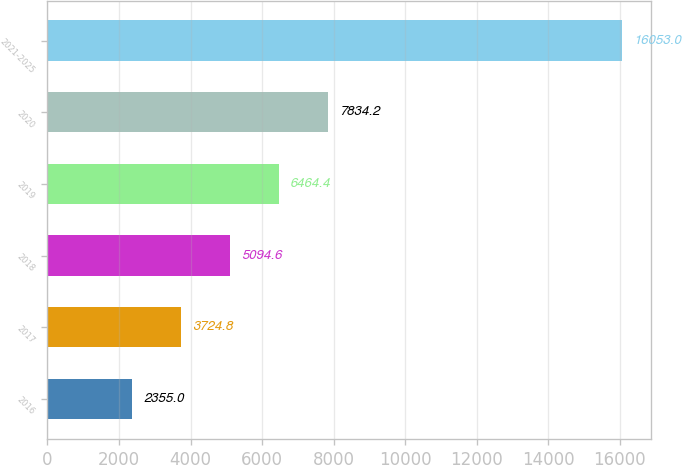<chart> <loc_0><loc_0><loc_500><loc_500><bar_chart><fcel>2016<fcel>2017<fcel>2018<fcel>2019<fcel>2020<fcel>2021-2025<nl><fcel>2355<fcel>3724.8<fcel>5094.6<fcel>6464.4<fcel>7834.2<fcel>16053<nl></chart> 